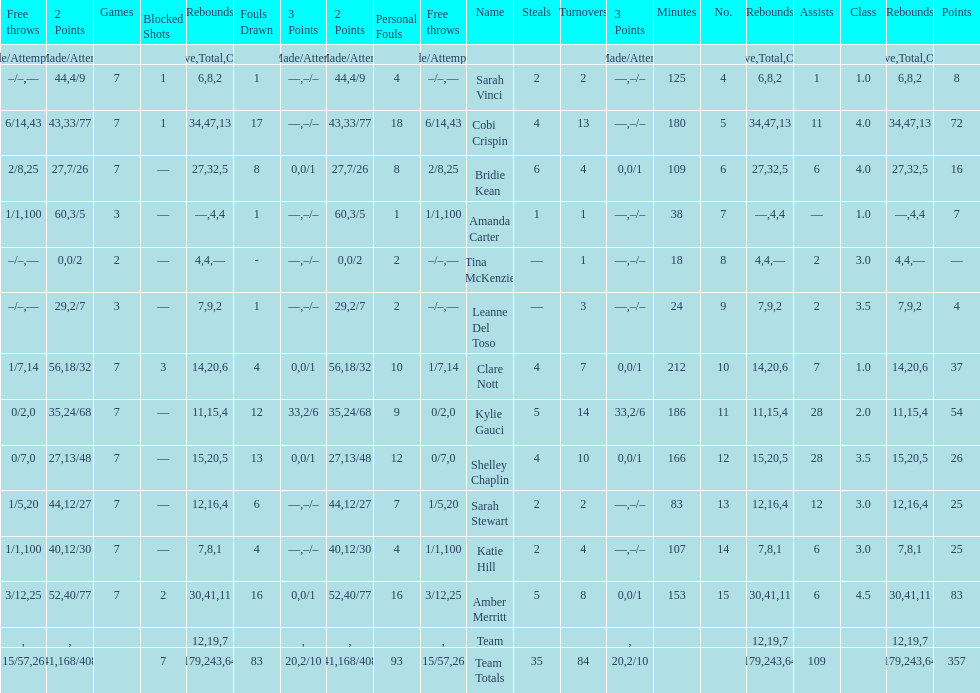Which player played in the least games? Tina McKenzie. 